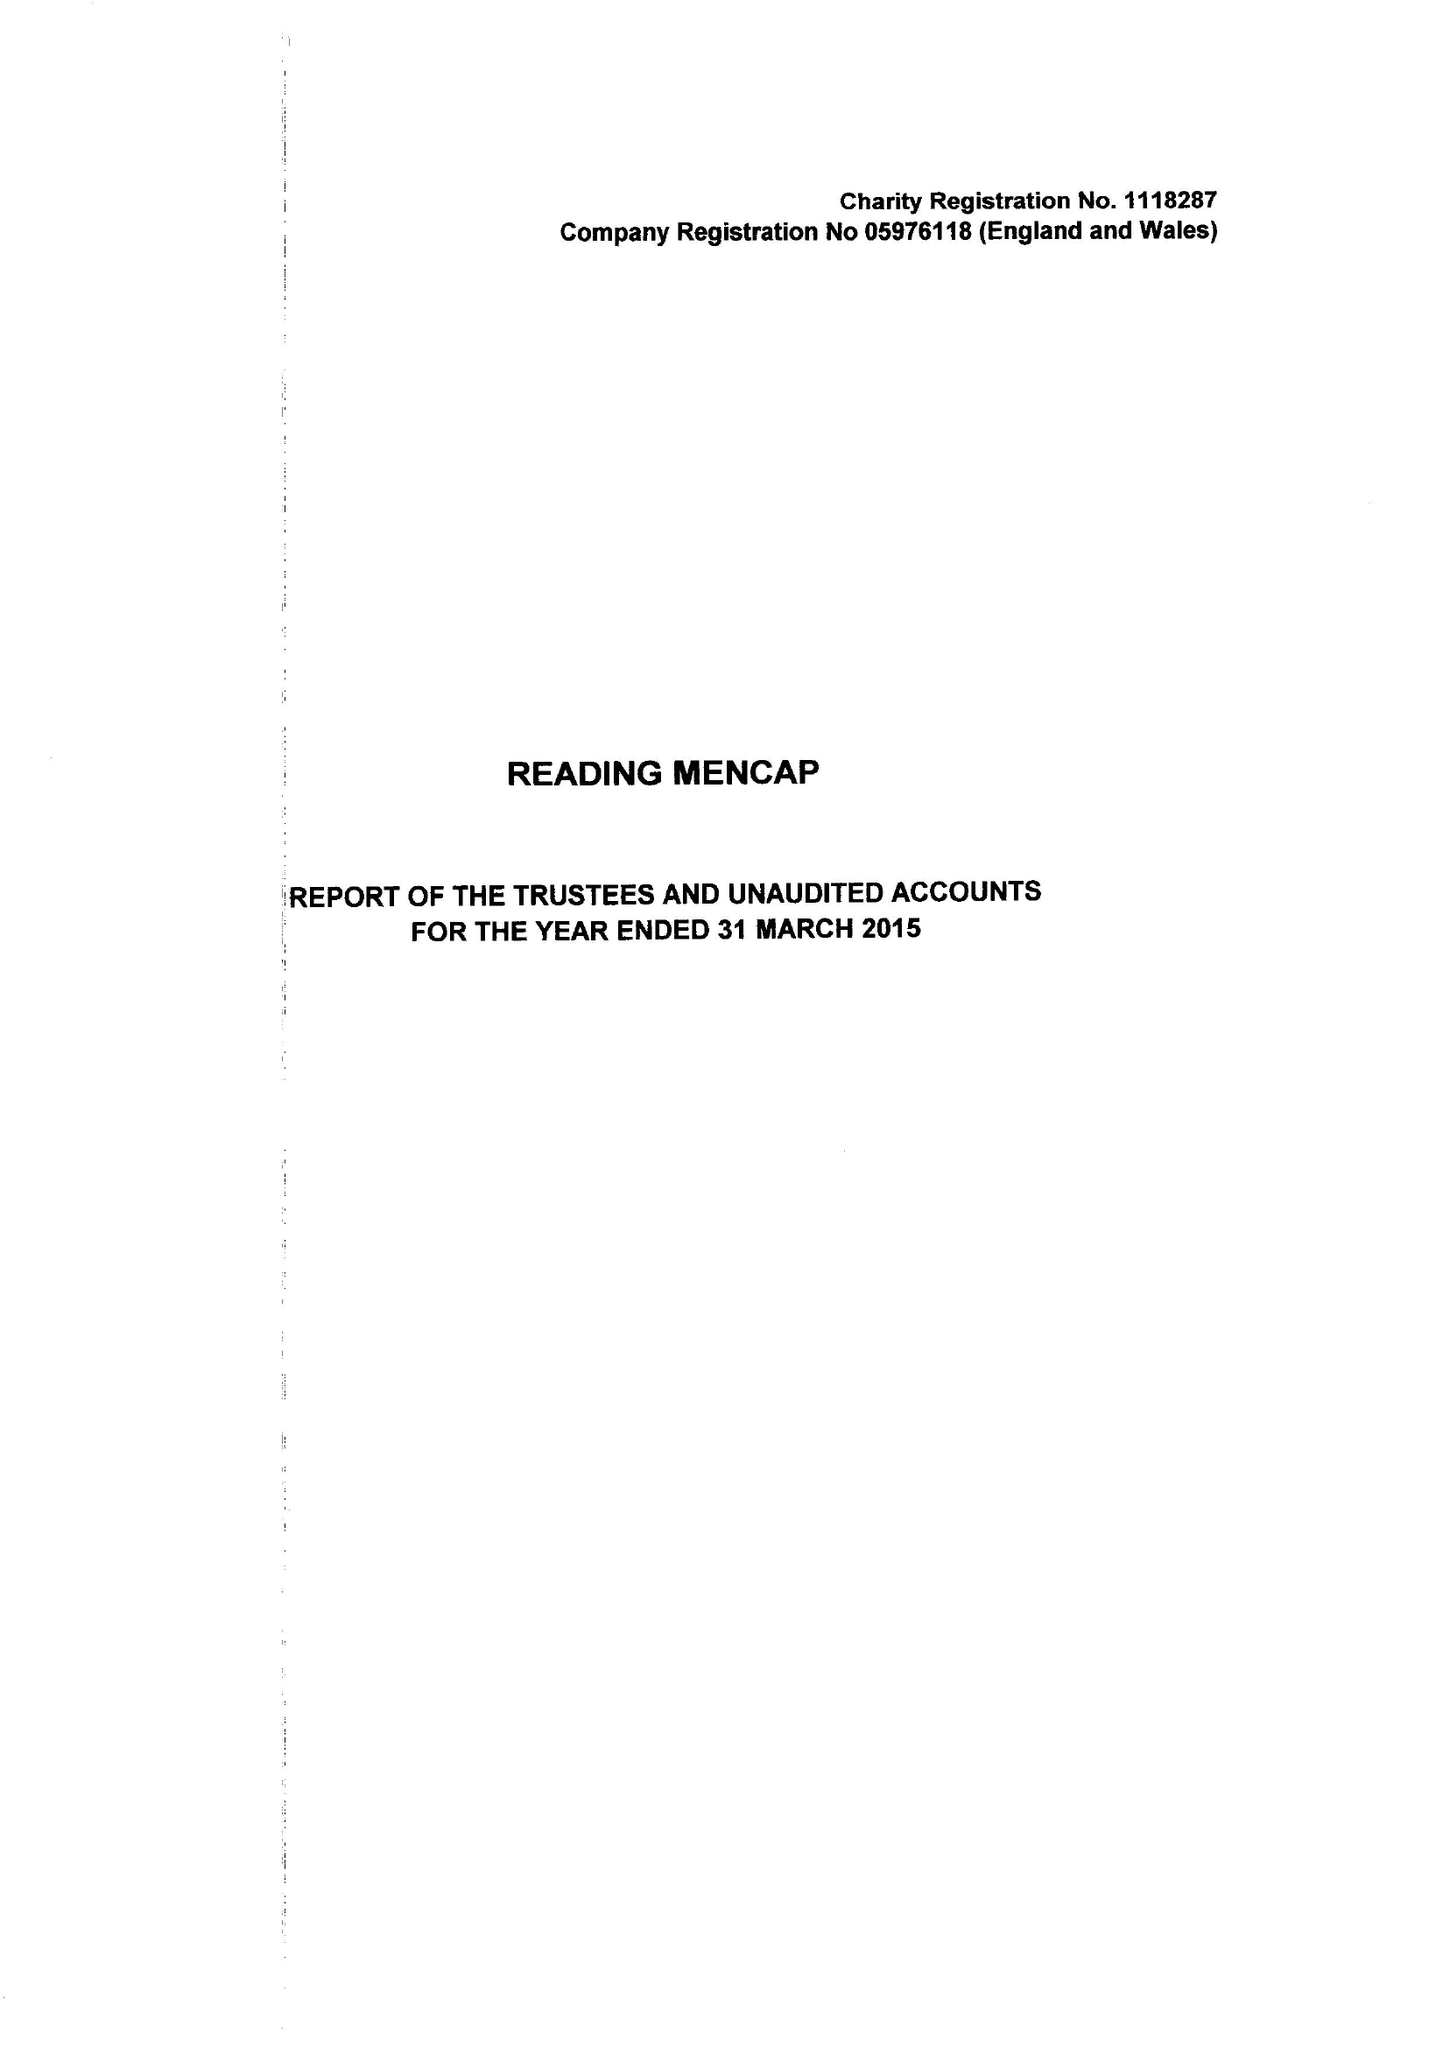What is the value for the charity_number?
Answer the question using a single word or phrase. 1118287 